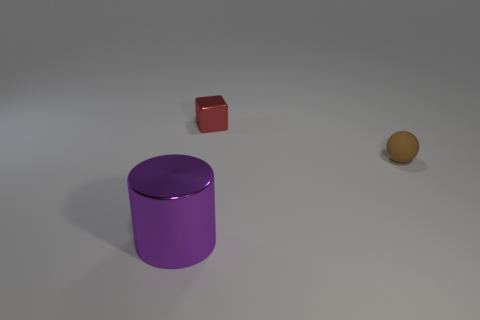Is there anything else that has the same size as the purple metallic thing?
Offer a terse response. No. The object that is behind the brown object is what color?
Your answer should be very brief. Red. There is a metal thing that is behind the object that is in front of the small matte thing; how many tiny things are right of it?
Ensure brevity in your answer.  1. There is a thing that is to the right of the tiny red block; what number of purple objects are in front of it?
Make the answer very short. 1. There is a red metallic cube; what number of tiny rubber balls are in front of it?
Your response must be concise. 1. How many other objects are there of the same size as the metal cylinder?
Your response must be concise. 0. There is a small thing in front of the small red shiny cube; what is its shape?
Make the answer very short. Sphere. The metallic object that is behind the metallic thing on the left side of the small shiny cube is what color?
Provide a short and direct response. Red. How many objects are small rubber things on the right side of the metallic cube or big rubber cylinders?
Provide a short and direct response. 1. There is a brown rubber thing; is it the same size as the shiny object behind the tiny brown rubber ball?
Your answer should be very brief. Yes. 